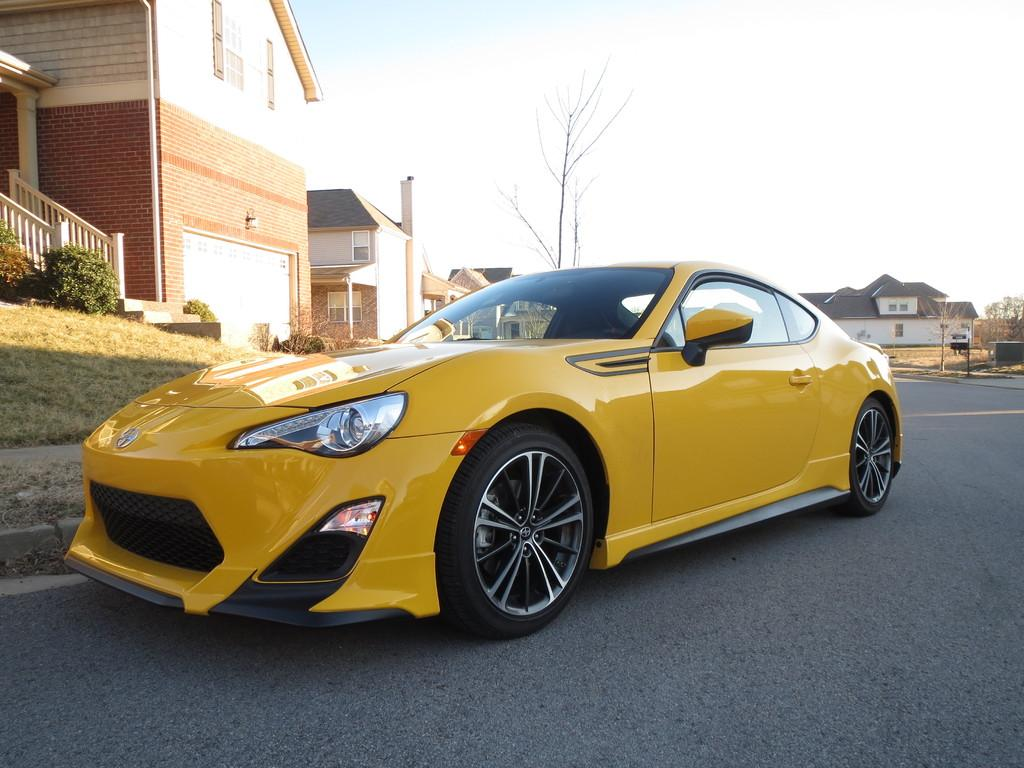What type of structures can be seen in the image? There are buildings in the image. What architectural feature is visible on the buildings? There are windows visible in the image. What type of vegetation is present in the image? There are trees in the image. Are there any stairs visible in the image? Yes, there are stairs in the image. What mode of transportation can be seen on the road in the image? There is a yellow car on the road in the image. What colors can be seen in the sky in the image? The sky is white and blue in color. What level of difficulty does the beginner face when making a discovery in the image? There is no indication of a beginner or any discovery in the image; it primarily features buildings, windows, trees, stairs, a yellow car, and a white and blue sky. 